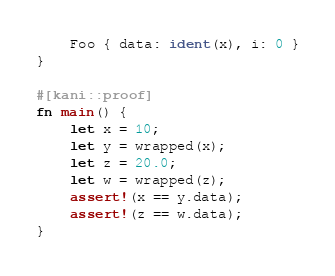<code> <loc_0><loc_0><loc_500><loc_500><_Rust_>    Foo { data: ident(x), i: 0 }
}

#[kani::proof]
fn main() {
    let x = 10;
    let y = wrapped(x);
    let z = 20.0;
    let w = wrapped(z);
    assert!(x == y.data);
    assert!(z == w.data);
}
</code> 